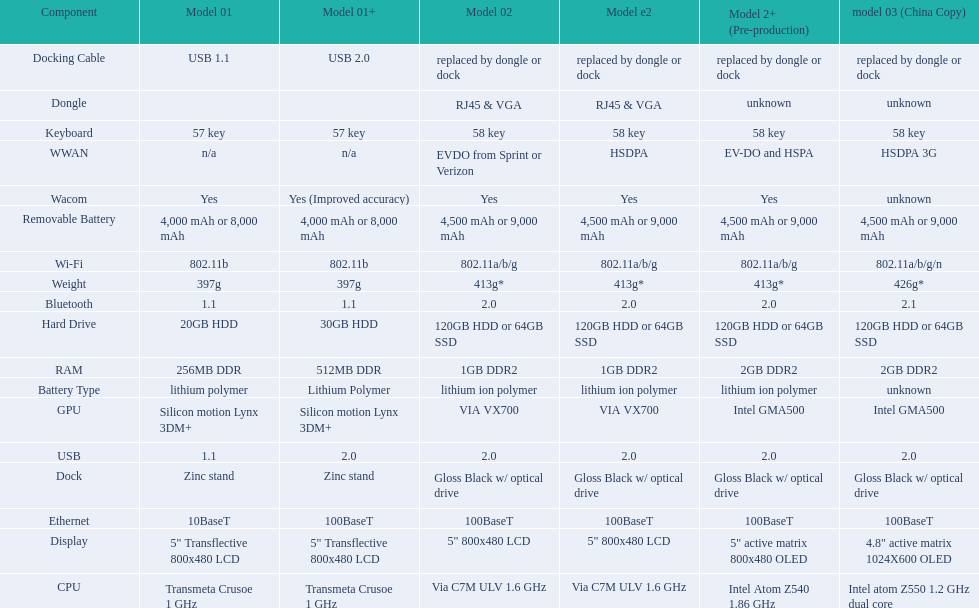Are there a minimum of 13 distinct elements on the diagram? Yes. 